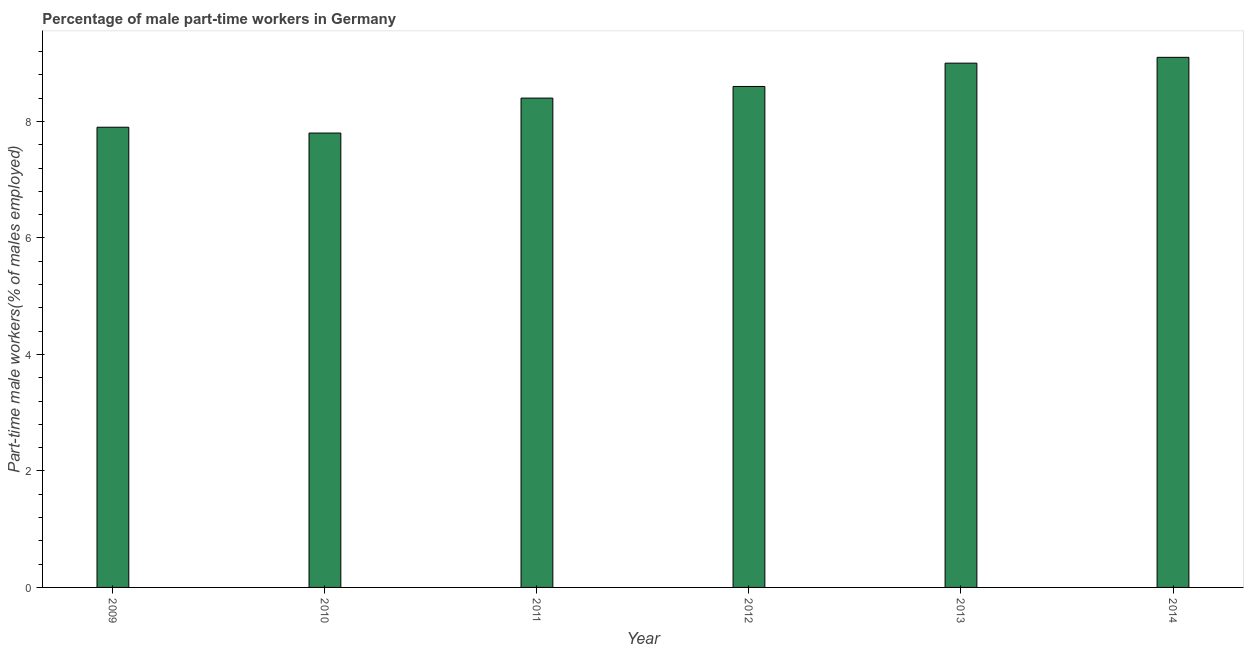Does the graph contain grids?
Your response must be concise. No. What is the title of the graph?
Your answer should be compact. Percentage of male part-time workers in Germany. What is the label or title of the Y-axis?
Provide a short and direct response. Part-time male workers(% of males employed). What is the percentage of part-time male workers in 2010?
Provide a short and direct response. 7.8. Across all years, what is the maximum percentage of part-time male workers?
Give a very brief answer. 9.1. Across all years, what is the minimum percentage of part-time male workers?
Offer a very short reply. 7.8. In which year was the percentage of part-time male workers maximum?
Provide a succinct answer. 2014. What is the sum of the percentage of part-time male workers?
Offer a terse response. 50.8. What is the average percentage of part-time male workers per year?
Make the answer very short. 8.47. In how many years, is the percentage of part-time male workers greater than 0.4 %?
Give a very brief answer. 6. Do a majority of the years between 2014 and 2012 (inclusive) have percentage of part-time male workers greater than 2.8 %?
Your answer should be very brief. Yes. What is the ratio of the percentage of part-time male workers in 2009 to that in 2012?
Provide a succinct answer. 0.92. What is the difference between the highest and the second highest percentage of part-time male workers?
Offer a very short reply. 0.1. Is the sum of the percentage of part-time male workers in 2010 and 2013 greater than the maximum percentage of part-time male workers across all years?
Offer a very short reply. Yes. In how many years, is the percentage of part-time male workers greater than the average percentage of part-time male workers taken over all years?
Your response must be concise. 3. How many bars are there?
Make the answer very short. 6. Are the values on the major ticks of Y-axis written in scientific E-notation?
Your answer should be compact. No. What is the Part-time male workers(% of males employed) in 2009?
Keep it short and to the point. 7.9. What is the Part-time male workers(% of males employed) in 2010?
Give a very brief answer. 7.8. What is the Part-time male workers(% of males employed) in 2011?
Keep it short and to the point. 8.4. What is the Part-time male workers(% of males employed) of 2012?
Your answer should be compact. 8.6. What is the Part-time male workers(% of males employed) of 2013?
Offer a terse response. 9. What is the Part-time male workers(% of males employed) of 2014?
Your answer should be very brief. 9.1. What is the difference between the Part-time male workers(% of males employed) in 2009 and 2011?
Provide a short and direct response. -0.5. What is the difference between the Part-time male workers(% of males employed) in 2009 and 2014?
Keep it short and to the point. -1.2. What is the difference between the Part-time male workers(% of males employed) in 2010 and 2013?
Your answer should be compact. -1.2. What is the difference between the Part-time male workers(% of males employed) in 2010 and 2014?
Your answer should be very brief. -1.3. What is the difference between the Part-time male workers(% of males employed) in 2011 and 2013?
Ensure brevity in your answer.  -0.6. What is the difference between the Part-time male workers(% of males employed) in 2012 and 2014?
Keep it short and to the point. -0.5. What is the difference between the Part-time male workers(% of males employed) in 2013 and 2014?
Provide a succinct answer. -0.1. What is the ratio of the Part-time male workers(% of males employed) in 2009 to that in 2010?
Keep it short and to the point. 1.01. What is the ratio of the Part-time male workers(% of males employed) in 2009 to that in 2011?
Your answer should be compact. 0.94. What is the ratio of the Part-time male workers(% of males employed) in 2009 to that in 2012?
Offer a terse response. 0.92. What is the ratio of the Part-time male workers(% of males employed) in 2009 to that in 2013?
Offer a very short reply. 0.88. What is the ratio of the Part-time male workers(% of males employed) in 2009 to that in 2014?
Provide a short and direct response. 0.87. What is the ratio of the Part-time male workers(% of males employed) in 2010 to that in 2011?
Your answer should be compact. 0.93. What is the ratio of the Part-time male workers(% of males employed) in 2010 to that in 2012?
Keep it short and to the point. 0.91. What is the ratio of the Part-time male workers(% of males employed) in 2010 to that in 2013?
Your answer should be very brief. 0.87. What is the ratio of the Part-time male workers(% of males employed) in 2010 to that in 2014?
Give a very brief answer. 0.86. What is the ratio of the Part-time male workers(% of males employed) in 2011 to that in 2012?
Your response must be concise. 0.98. What is the ratio of the Part-time male workers(% of males employed) in 2011 to that in 2013?
Give a very brief answer. 0.93. What is the ratio of the Part-time male workers(% of males employed) in 2011 to that in 2014?
Your answer should be very brief. 0.92. What is the ratio of the Part-time male workers(% of males employed) in 2012 to that in 2013?
Your response must be concise. 0.96. What is the ratio of the Part-time male workers(% of males employed) in 2012 to that in 2014?
Your answer should be very brief. 0.94. 